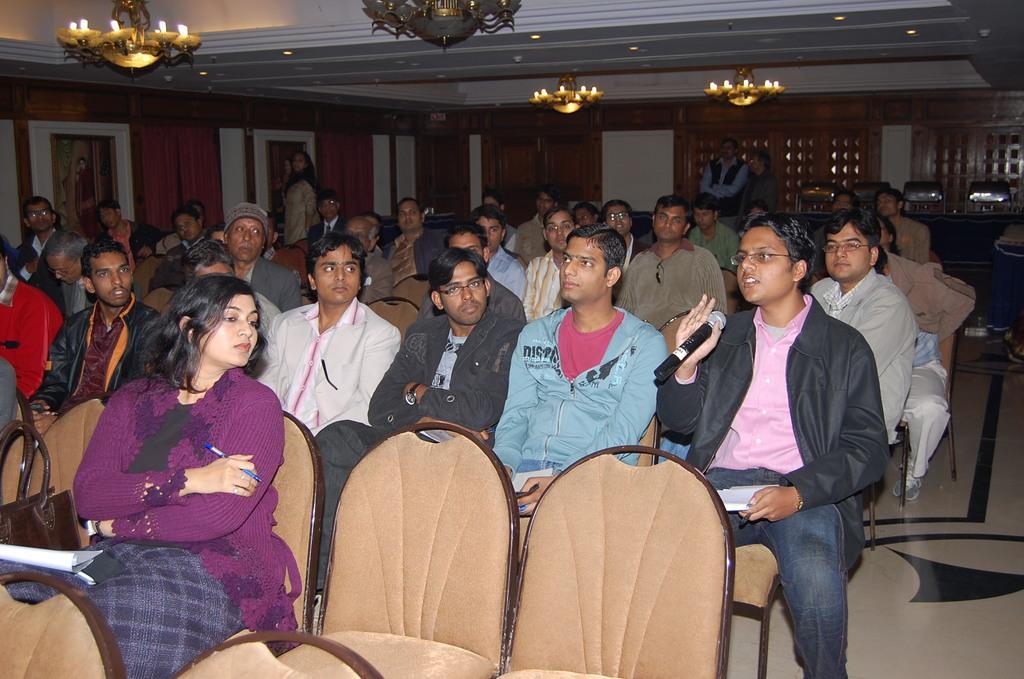Describe this image in one or two sentences. This is the picture of a room. In this image there are group of people sitting on the chair. In the foreground there is a woman sitting and holding the pen. There is a person with black jacket is sitting and holding the microphone and he is talking. At the back there is a door. At the top there are lights. 